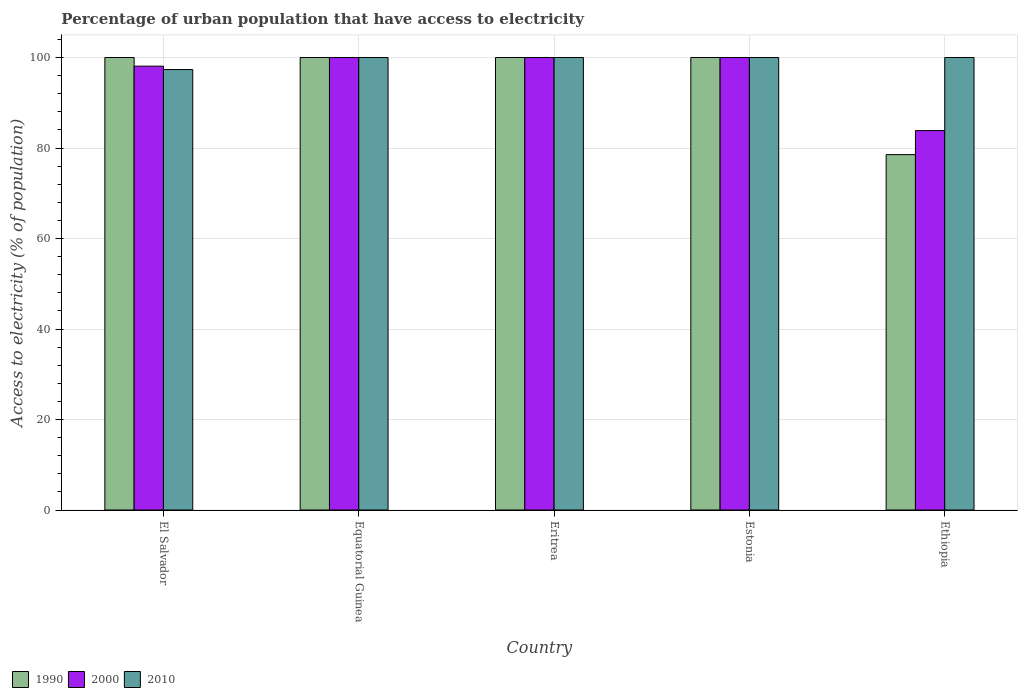How many different coloured bars are there?
Your response must be concise. 3. How many groups of bars are there?
Your answer should be compact. 5. Are the number of bars on each tick of the X-axis equal?
Provide a short and direct response. Yes. How many bars are there on the 2nd tick from the left?
Make the answer very short. 3. How many bars are there on the 5th tick from the right?
Provide a short and direct response. 3. What is the label of the 1st group of bars from the left?
Ensure brevity in your answer.  El Salvador. What is the percentage of urban population that have access to electricity in 2000 in El Salvador?
Provide a succinct answer. 98.09. Across all countries, what is the minimum percentage of urban population that have access to electricity in 2010?
Your answer should be very brief. 97.33. In which country was the percentage of urban population that have access to electricity in 2010 maximum?
Give a very brief answer. Equatorial Guinea. In which country was the percentage of urban population that have access to electricity in 2010 minimum?
Make the answer very short. El Salvador. What is the total percentage of urban population that have access to electricity in 2000 in the graph?
Make the answer very short. 481.94. What is the difference between the percentage of urban population that have access to electricity in 1990 in Eritrea and that in Estonia?
Ensure brevity in your answer.  0. What is the difference between the percentage of urban population that have access to electricity in 2010 in Equatorial Guinea and the percentage of urban population that have access to electricity in 2000 in Ethiopia?
Give a very brief answer. 16.15. What is the average percentage of urban population that have access to electricity in 2000 per country?
Your answer should be compact. 96.39. What is the difference between the percentage of urban population that have access to electricity of/in 1990 and percentage of urban population that have access to electricity of/in 2010 in El Salvador?
Offer a terse response. 2.67. What is the ratio of the percentage of urban population that have access to electricity in 2000 in El Salvador to that in Ethiopia?
Keep it short and to the point. 1.17. Is the percentage of urban population that have access to electricity in 2010 in El Salvador less than that in Eritrea?
Your answer should be very brief. Yes. Is the difference between the percentage of urban population that have access to electricity in 1990 in El Salvador and Equatorial Guinea greater than the difference between the percentage of urban population that have access to electricity in 2010 in El Salvador and Equatorial Guinea?
Your answer should be very brief. Yes. What is the difference between the highest and the lowest percentage of urban population that have access to electricity in 2010?
Your response must be concise. 2.67. What does the 2nd bar from the right in Eritrea represents?
Provide a short and direct response. 2000. Is it the case that in every country, the sum of the percentage of urban population that have access to electricity in 2000 and percentage of urban population that have access to electricity in 2010 is greater than the percentage of urban population that have access to electricity in 1990?
Ensure brevity in your answer.  Yes. How many bars are there?
Keep it short and to the point. 15. Does the graph contain any zero values?
Give a very brief answer. No. Does the graph contain grids?
Provide a short and direct response. Yes. How are the legend labels stacked?
Offer a terse response. Horizontal. What is the title of the graph?
Ensure brevity in your answer.  Percentage of urban population that have access to electricity. What is the label or title of the X-axis?
Ensure brevity in your answer.  Country. What is the label or title of the Y-axis?
Your response must be concise. Access to electricity (% of population). What is the Access to electricity (% of population) in 1990 in El Salvador?
Your answer should be compact. 100. What is the Access to electricity (% of population) of 2000 in El Salvador?
Offer a very short reply. 98.09. What is the Access to electricity (% of population) in 2010 in El Salvador?
Make the answer very short. 97.33. What is the Access to electricity (% of population) in 1990 in Equatorial Guinea?
Keep it short and to the point. 100. What is the Access to electricity (% of population) in 2010 in Equatorial Guinea?
Provide a short and direct response. 100. What is the Access to electricity (% of population) of 1990 in Eritrea?
Your answer should be compact. 100. What is the Access to electricity (% of population) in 1990 in Ethiopia?
Offer a terse response. 78.54. What is the Access to electricity (% of population) in 2000 in Ethiopia?
Your response must be concise. 83.85. Across all countries, what is the maximum Access to electricity (% of population) in 2010?
Offer a terse response. 100. Across all countries, what is the minimum Access to electricity (% of population) in 1990?
Provide a short and direct response. 78.54. Across all countries, what is the minimum Access to electricity (% of population) of 2000?
Your response must be concise. 83.85. Across all countries, what is the minimum Access to electricity (% of population) in 2010?
Offer a terse response. 97.33. What is the total Access to electricity (% of population) of 1990 in the graph?
Keep it short and to the point. 478.54. What is the total Access to electricity (% of population) of 2000 in the graph?
Keep it short and to the point. 481.94. What is the total Access to electricity (% of population) in 2010 in the graph?
Make the answer very short. 497.33. What is the difference between the Access to electricity (% of population) of 1990 in El Salvador and that in Equatorial Guinea?
Provide a succinct answer. 0. What is the difference between the Access to electricity (% of population) of 2000 in El Salvador and that in Equatorial Guinea?
Offer a very short reply. -1.91. What is the difference between the Access to electricity (% of population) in 2010 in El Salvador and that in Equatorial Guinea?
Offer a terse response. -2.67. What is the difference between the Access to electricity (% of population) in 1990 in El Salvador and that in Eritrea?
Offer a very short reply. 0. What is the difference between the Access to electricity (% of population) in 2000 in El Salvador and that in Eritrea?
Provide a short and direct response. -1.91. What is the difference between the Access to electricity (% of population) of 2010 in El Salvador and that in Eritrea?
Keep it short and to the point. -2.67. What is the difference between the Access to electricity (% of population) in 1990 in El Salvador and that in Estonia?
Make the answer very short. 0. What is the difference between the Access to electricity (% of population) in 2000 in El Salvador and that in Estonia?
Offer a very short reply. -1.91. What is the difference between the Access to electricity (% of population) of 2010 in El Salvador and that in Estonia?
Your response must be concise. -2.67. What is the difference between the Access to electricity (% of population) of 1990 in El Salvador and that in Ethiopia?
Give a very brief answer. 21.46. What is the difference between the Access to electricity (% of population) in 2000 in El Salvador and that in Ethiopia?
Give a very brief answer. 14.24. What is the difference between the Access to electricity (% of population) in 2010 in El Salvador and that in Ethiopia?
Give a very brief answer. -2.67. What is the difference between the Access to electricity (% of population) in 2000 in Equatorial Guinea and that in Eritrea?
Provide a succinct answer. 0. What is the difference between the Access to electricity (% of population) of 1990 in Equatorial Guinea and that in Estonia?
Give a very brief answer. 0. What is the difference between the Access to electricity (% of population) of 1990 in Equatorial Guinea and that in Ethiopia?
Ensure brevity in your answer.  21.46. What is the difference between the Access to electricity (% of population) of 2000 in Equatorial Guinea and that in Ethiopia?
Provide a succinct answer. 16.15. What is the difference between the Access to electricity (% of population) of 1990 in Eritrea and that in Estonia?
Make the answer very short. 0. What is the difference between the Access to electricity (% of population) of 1990 in Eritrea and that in Ethiopia?
Your response must be concise. 21.46. What is the difference between the Access to electricity (% of population) in 2000 in Eritrea and that in Ethiopia?
Provide a short and direct response. 16.15. What is the difference between the Access to electricity (% of population) of 2010 in Eritrea and that in Ethiopia?
Provide a succinct answer. 0. What is the difference between the Access to electricity (% of population) of 1990 in Estonia and that in Ethiopia?
Your response must be concise. 21.46. What is the difference between the Access to electricity (% of population) in 2000 in Estonia and that in Ethiopia?
Offer a terse response. 16.15. What is the difference between the Access to electricity (% of population) of 2010 in Estonia and that in Ethiopia?
Your response must be concise. 0. What is the difference between the Access to electricity (% of population) of 1990 in El Salvador and the Access to electricity (% of population) of 2010 in Equatorial Guinea?
Your answer should be very brief. 0. What is the difference between the Access to electricity (% of population) of 2000 in El Salvador and the Access to electricity (% of population) of 2010 in Equatorial Guinea?
Keep it short and to the point. -1.91. What is the difference between the Access to electricity (% of population) in 1990 in El Salvador and the Access to electricity (% of population) in 2000 in Eritrea?
Ensure brevity in your answer.  0. What is the difference between the Access to electricity (% of population) of 2000 in El Salvador and the Access to electricity (% of population) of 2010 in Eritrea?
Offer a terse response. -1.91. What is the difference between the Access to electricity (% of population) of 2000 in El Salvador and the Access to electricity (% of population) of 2010 in Estonia?
Keep it short and to the point. -1.91. What is the difference between the Access to electricity (% of population) in 1990 in El Salvador and the Access to electricity (% of population) in 2000 in Ethiopia?
Your answer should be very brief. 16.15. What is the difference between the Access to electricity (% of population) of 2000 in El Salvador and the Access to electricity (% of population) of 2010 in Ethiopia?
Make the answer very short. -1.91. What is the difference between the Access to electricity (% of population) of 1990 in Equatorial Guinea and the Access to electricity (% of population) of 2000 in Eritrea?
Your answer should be compact. 0. What is the difference between the Access to electricity (% of population) of 2000 in Equatorial Guinea and the Access to electricity (% of population) of 2010 in Eritrea?
Keep it short and to the point. 0. What is the difference between the Access to electricity (% of population) in 1990 in Equatorial Guinea and the Access to electricity (% of population) in 2000 in Estonia?
Offer a very short reply. 0. What is the difference between the Access to electricity (% of population) of 1990 in Equatorial Guinea and the Access to electricity (% of population) of 2010 in Estonia?
Give a very brief answer. 0. What is the difference between the Access to electricity (% of population) of 1990 in Equatorial Guinea and the Access to electricity (% of population) of 2000 in Ethiopia?
Provide a short and direct response. 16.15. What is the difference between the Access to electricity (% of population) of 1990 in Equatorial Guinea and the Access to electricity (% of population) of 2010 in Ethiopia?
Offer a very short reply. 0. What is the difference between the Access to electricity (% of population) in 1990 in Eritrea and the Access to electricity (% of population) in 2010 in Estonia?
Provide a succinct answer. 0. What is the difference between the Access to electricity (% of population) in 2000 in Eritrea and the Access to electricity (% of population) in 2010 in Estonia?
Your response must be concise. 0. What is the difference between the Access to electricity (% of population) of 1990 in Eritrea and the Access to electricity (% of population) of 2000 in Ethiopia?
Your answer should be compact. 16.15. What is the difference between the Access to electricity (% of population) of 2000 in Eritrea and the Access to electricity (% of population) of 2010 in Ethiopia?
Ensure brevity in your answer.  0. What is the difference between the Access to electricity (% of population) in 1990 in Estonia and the Access to electricity (% of population) in 2000 in Ethiopia?
Give a very brief answer. 16.15. What is the difference between the Access to electricity (% of population) in 1990 in Estonia and the Access to electricity (% of population) in 2010 in Ethiopia?
Your response must be concise. 0. What is the average Access to electricity (% of population) of 1990 per country?
Provide a short and direct response. 95.71. What is the average Access to electricity (% of population) in 2000 per country?
Make the answer very short. 96.39. What is the average Access to electricity (% of population) in 2010 per country?
Your answer should be very brief. 99.47. What is the difference between the Access to electricity (% of population) in 1990 and Access to electricity (% of population) in 2000 in El Salvador?
Your response must be concise. 1.91. What is the difference between the Access to electricity (% of population) of 1990 and Access to electricity (% of population) of 2010 in El Salvador?
Your answer should be very brief. 2.67. What is the difference between the Access to electricity (% of population) in 2000 and Access to electricity (% of population) in 2010 in El Salvador?
Give a very brief answer. 0.75. What is the difference between the Access to electricity (% of population) in 1990 and Access to electricity (% of population) in 2010 in Equatorial Guinea?
Offer a very short reply. 0. What is the difference between the Access to electricity (% of population) in 1990 and Access to electricity (% of population) in 2000 in Eritrea?
Provide a succinct answer. 0. What is the difference between the Access to electricity (% of population) in 2000 and Access to electricity (% of population) in 2010 in Eritrea?
Your answer should be very brief. 0. What is the difference between the Access to electricity (% of population) in 1990 and Access to electricity (% of population) in 2000 in Ethiopia?
Give a very brief answer. -5.31. What is the difference between the Access to electricity (% of population) of 1990 and Access to electricity (% of population) of 2010 in Ethiopia?
Your answer should be very brief. -21.46. What is the difference between the Access to electricity (% of population) of 2000 and Access to electricity (% of population) of 2010 in Ethiopia?
Your response must be concise. -16.15. What is the ratio of the Access to electricity (% of population) in 1990 in El Salvador to that in Equatorial Guinea?
Offer a very short reply. 1. What is the ratio of the Access to electricity (% of population) of 2000 in El Salvador to that in Equatorial Guinea?
Offer a terse response. 0.98. What is the ratio of the Access to electricity (% of population) in 2010 in El Salvador to that in Equatorial Guinea?
Your answer should be very brief. 0.97. What is the ratio of the Access to electricity (% of population) of 2000 in El Salvador to that in Eritrea?
Your answer should be very brief. 0.98. What is the ratio of the Access to electricity (% of population) of 2010 in El Salvador to that in Eritrea?
Your response must be concise. 0.97. What is the ratio of the Access to electricity (% of population) of 2000 in El Salvador to that in Estonia?
Your answer should be compact. 0.98. What is the ratio of the Access to electricity (% of population) of 2010 in El Salvador to that in Estonia?
Ensure brevity in your answer.  0.97. What is the ratio of the Access to electricity (% of population) of 1990 in El Salvador to that in Ethiopia?
Make the answer very short. 1.27. What is the ratio of the Access to electricity (% of population) of 2000 in El Salvador to that in Ethiopia?
Your answer should be compact. 1.17. What is the ratio of the Access to electricity (% of population) in 2010 in El Salvador to that in Ethiopia?
Give a very brief answer. 0.97. What is the ratio of the Access to electricity (% of population) in 1990 in Equatorial Guinea to that in Estonia?
Your response must be concise. 1. What is the ratio of the Access to electricity (% of population) of 2000 in Equatorial Guinea to that in Estonia?
Give a very brief answer. 1. What is the ratio of the Access to electricity (% of population) of 2010 in Equatorial Guinea to that in Estonia?
Give a very brief answer. 1. What is the ratio of the Access to electricity (% of population) in 1990 in Equatorial Guinea to that in Ethiopia?
Provide a succinct answer. 1.27. What is the ratio of the Access to electricity (% of population) in 2000 in Equatorial Guinea to that in Ethiopia?
Offer a very short reply. 1.19. What is the ratio of the Access to electricity (% of population) in 2010 in Equatorial Guinea to that in Ethiopia?
Your response must be concise. 1. What is the ratio of the Access to electricity (% of population) in 1990 in Eritrea to that in Estonia?
Your response must be concise. 1. What is the ratio of the Access to electricity (% of population) in 2000 in Eritrea to that in Estonia?
Provide a short and direct response. 1. What is the ratio of the Access to electricity (% of population) in 2010 in Eritrea to that in Estonia?
Your answer should be compact. 1. What is the ratio of the Access to electricity (% of population) in 1990 in Eritrea to that in Ethiopia?
Your answer should be very brief. 1.27. What is the ratio of the Access to electricity (% of population) in 2000 in Eritrea to that in Ethiopia?
Offer a very short reply. 1.19. What is the ratio of the Access to electricity (% of population) of 1990 in Estonia to that in Ethiopia?
Your answer should be very brief. 1.27. What is the ratio of the Access to electricity (% of population) in 2000 in Estonia to that in Ethiopia?
Provide a succinct answer. 1.19. What is the difference between the highest and the second highest Access to electricity (% of population) of 2000?
Provide a succinct answer. 0. What is the difference between the highest and the lowest Access to electricity (% of population) of 1990?
Give a very brief answer. 21.46. What is the difference between the highest and the lowest Access to electricity (% of population) of 2000?
Your response must be concise. 16.15. What is the difference between the highest and the lowest Access to electricity (% of population) of 2010?
Your answer should be very brief. 2.67. 